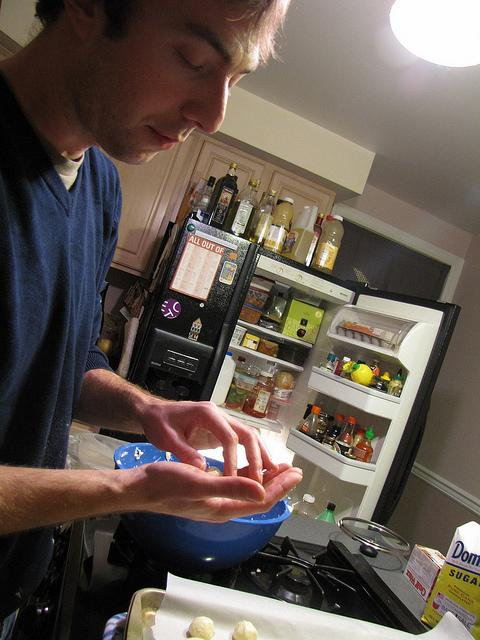What type of kitchen is shown? Please explain your reasoning. residential. The other options would be larger and more metallic. 